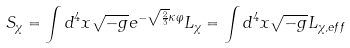<formula> <loc_0><loc_0><loc_500><loc_500>S _ { \chi } = \int d ^ { 4 } x \sqrt { - g } e ^ { - \sqrt { \frac { 2 } { 3 } } \kappa \varphi } L _ { \chi } = \int d ^ { 4 } x \sqrt { - g } L _ { \chi , e f f }</formula> 